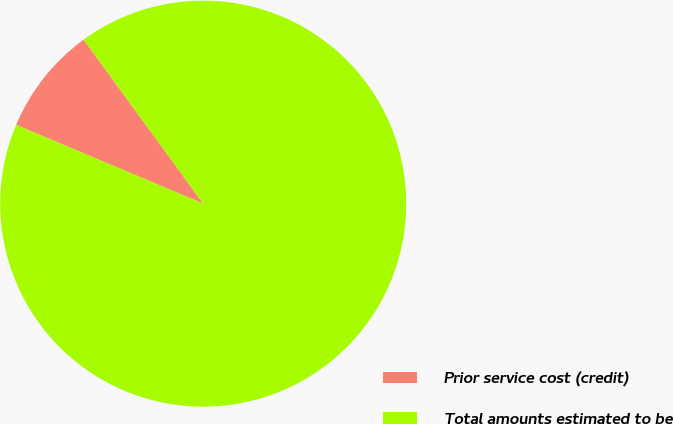<chart> <loc_0><loc_0><loc_500><loc_500><pie_chart><fcel>Prior service cost (credit)<fcel>Total amounts estimated to be<nl><fcel>8.64%<fcel>91.36%<nl></chart> 